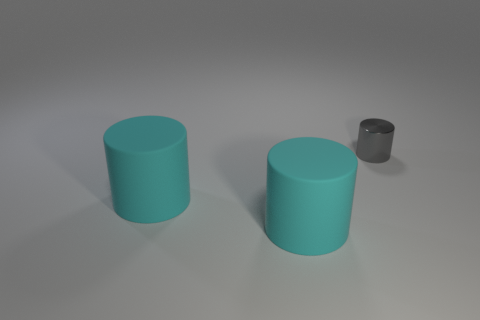Is there any other thing that has the same material as the small gray cylinder?
Offer a very short reply. No. Are there an equal number of tiny shiny things to the left of the tiny gray thing and cyan rubber cylinders?
Keep it short and to the point. No. How many other things have the same shape as the shiny object?
Provide a short and direct response. 2. Is the number of big matte objects that are in front of the gray cylinder less than the number of small matte blocks?
Keep it short and to the point. No. Are there any big blue metallic cylinders?
Your response must be concise. No. What color is the small shiny thing?
Your response must be concise. Gray. How many objects are either cylinders that are left of the tiny gray cylinder or tiny metal cylinders?
Provide a succinct answer. 3. How many things are either objects left of the gray shiny cylinder or things that are in front of the gray shiny thing?
Keep it short and to the point. 2. Are there any large rubber objects of the same shape as the small metal thing?
Offer a very short reply. Yes. Are there fewer tiny things than large yellow metal blocks?
Provide a short and direct response. No. 